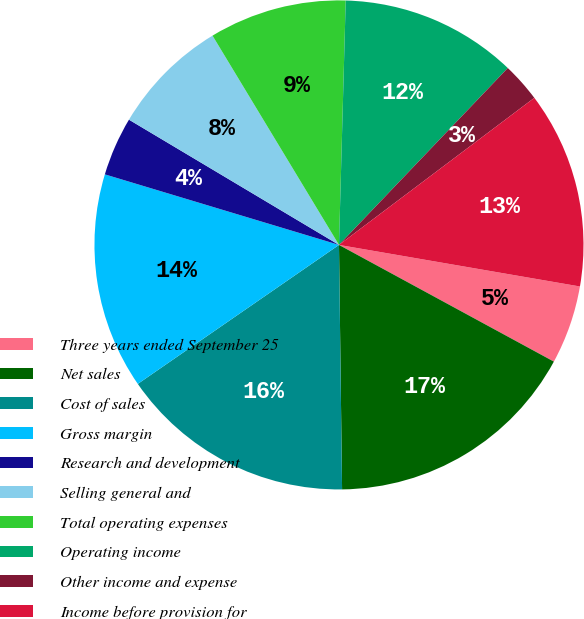Convert chart. <chart><loc_0><loc_0><loc_500><loc_500><pie_chart><fcel>Three years ended September 25<fcel>Net sales<fcel>Cost of sales<fcel>Gross margin<fcel>Research and development<fcel>Selling general and<fcel>Total operating expenses<fcel>Operating income<fcel>Other income and expense<fcel>Income before provision for<nl><fcel>5.2%<fcel>16.88%<fcel>15.58%<fcel>14.28%<fcel>3.9%<fcel>7.79%<fcel>9.09%<fcel>11.69%<fcel>2.6%<fcel>12.99%<nl></chart> 